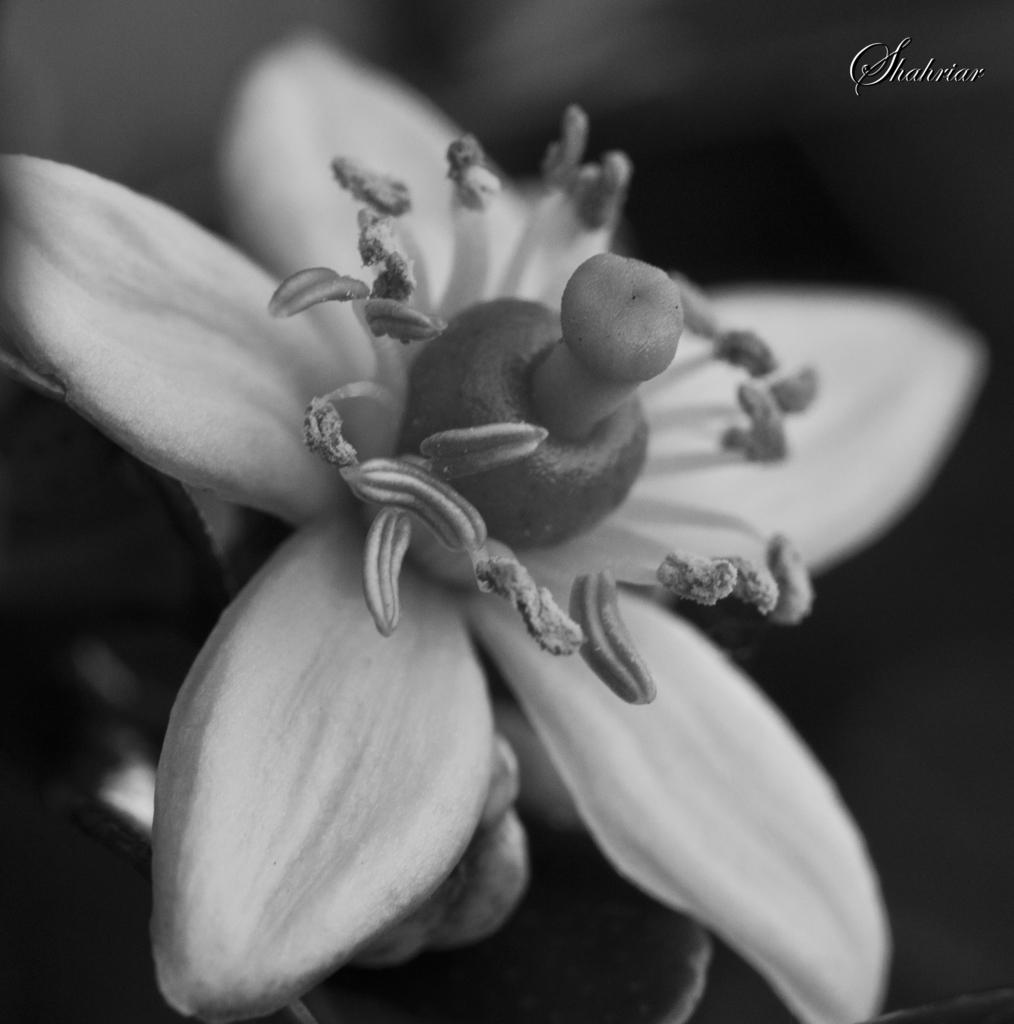What is the color scheme of the image? The image is black and white. What is the main subject of the image? There is a flower in the middle of the image. What can be found within the flower? Pollen grains are present in the flower. How many threads are attached to the worm in the image? There is no worm present in the image, and therefore no threads can be attached to it. 